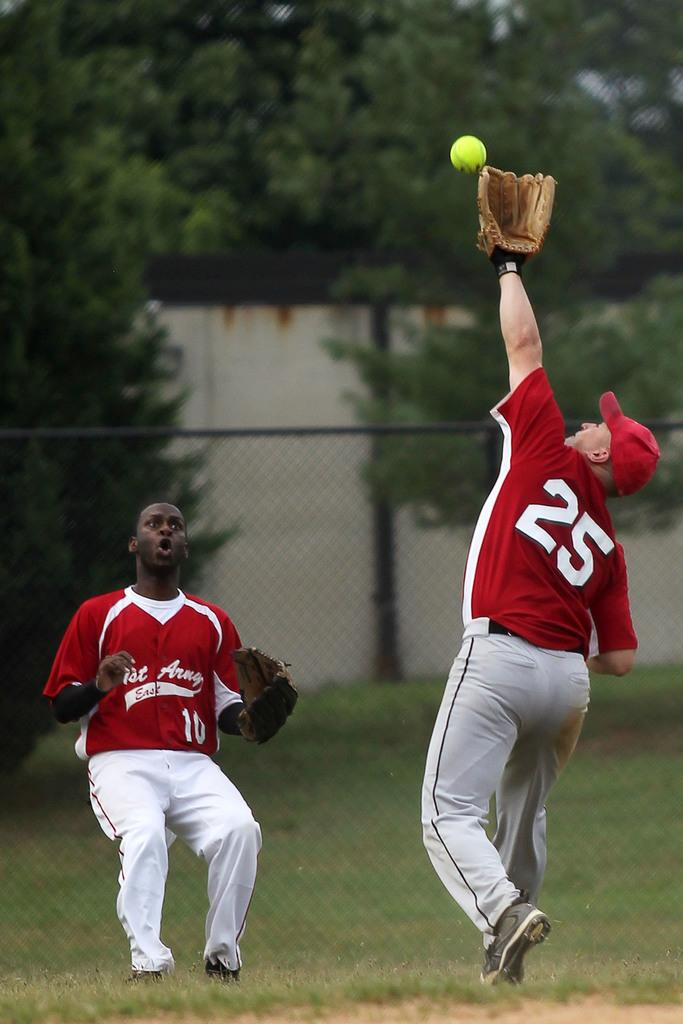Provide a one-sentence caption for the provided image. Number 10 is surprised that number 25 is trying to catch this ball. 